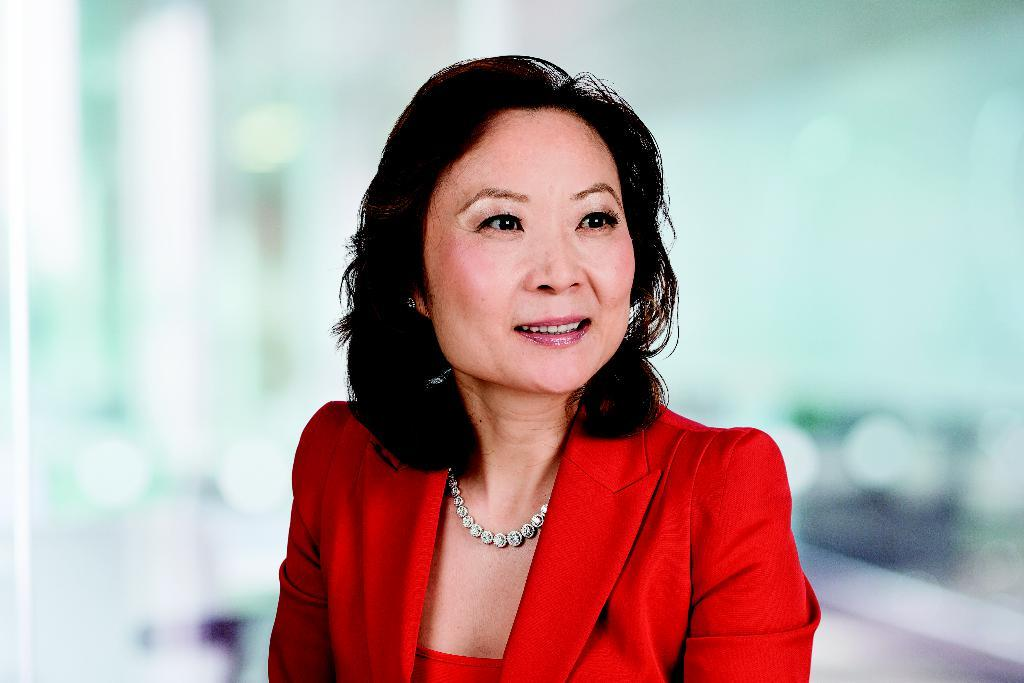Who is present in the image? There is a woman in the image. What is the woman doing in the image? The woman is looking to the right side. What is the woman wearing in the image? The woman is wearing a red coat. What type of toys can be seen in the woman's red coat? There are no toys visible in the image, and the woman's red coat does not contain any toys. 